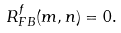Convert formula to latex. <formula><loc_0><loc_0><loc_500><loc_500>R _ { F B } ^ { f } ( m , n ) = 0 .</formula> 